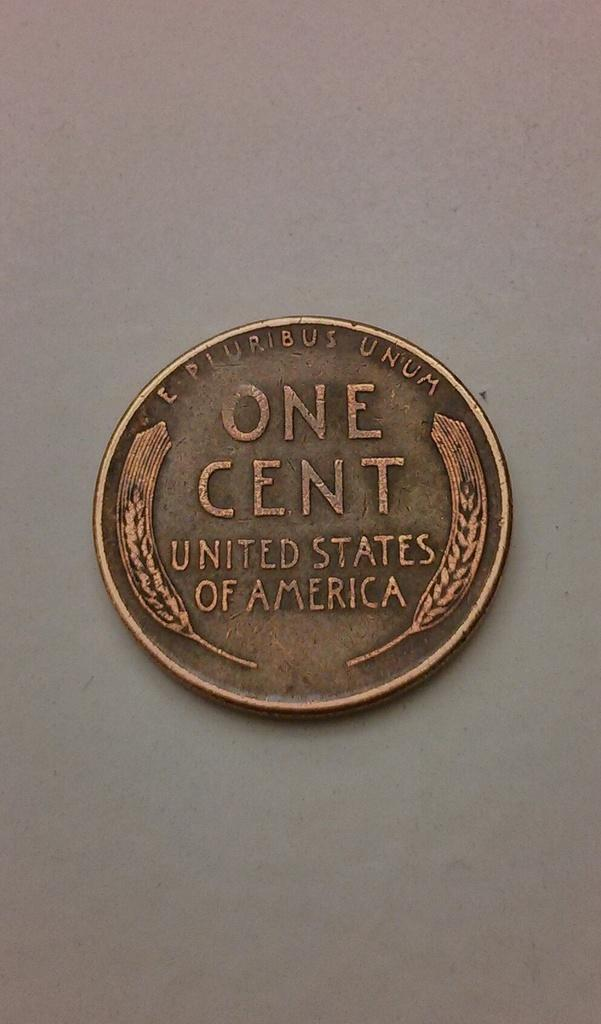<image>
Present a compact description of the photo's key features. A one cent piece minted in the United States of America. 